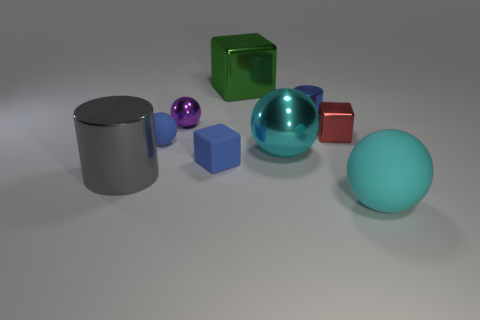Does the large ball behind the large matte object have the same color as the rubber sphere that is in front of the small matte ball? yes 